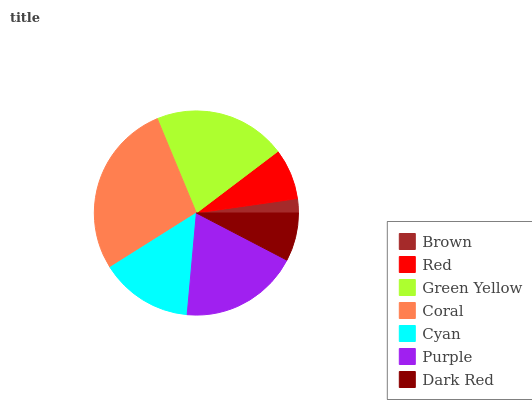Is Brown the minimum?
Answer yes or no. Yes. Is Coral the maximum?
Answer yes or no. Yes. Is Red the minimum?
Answer yes or no. No. Is Red the maximum?
Answer yes or no. No. Is Red greater than Brown?
Answer yes or no. Yes. Is Brown less than Red?
Answer yes or no. Yes. Is Brown greater than Red?
Answer yes or no. No. Is Red less than Brown?
Answer yes or no. No. Is Cyan the high median?
Answer yes or no. Yes. Is Cyan the low median?
Answer yes or no. Yes. Is Coral the high median?
Answer yes or no. No. Is Dark Red the low median?
Answer yes or no. No. 